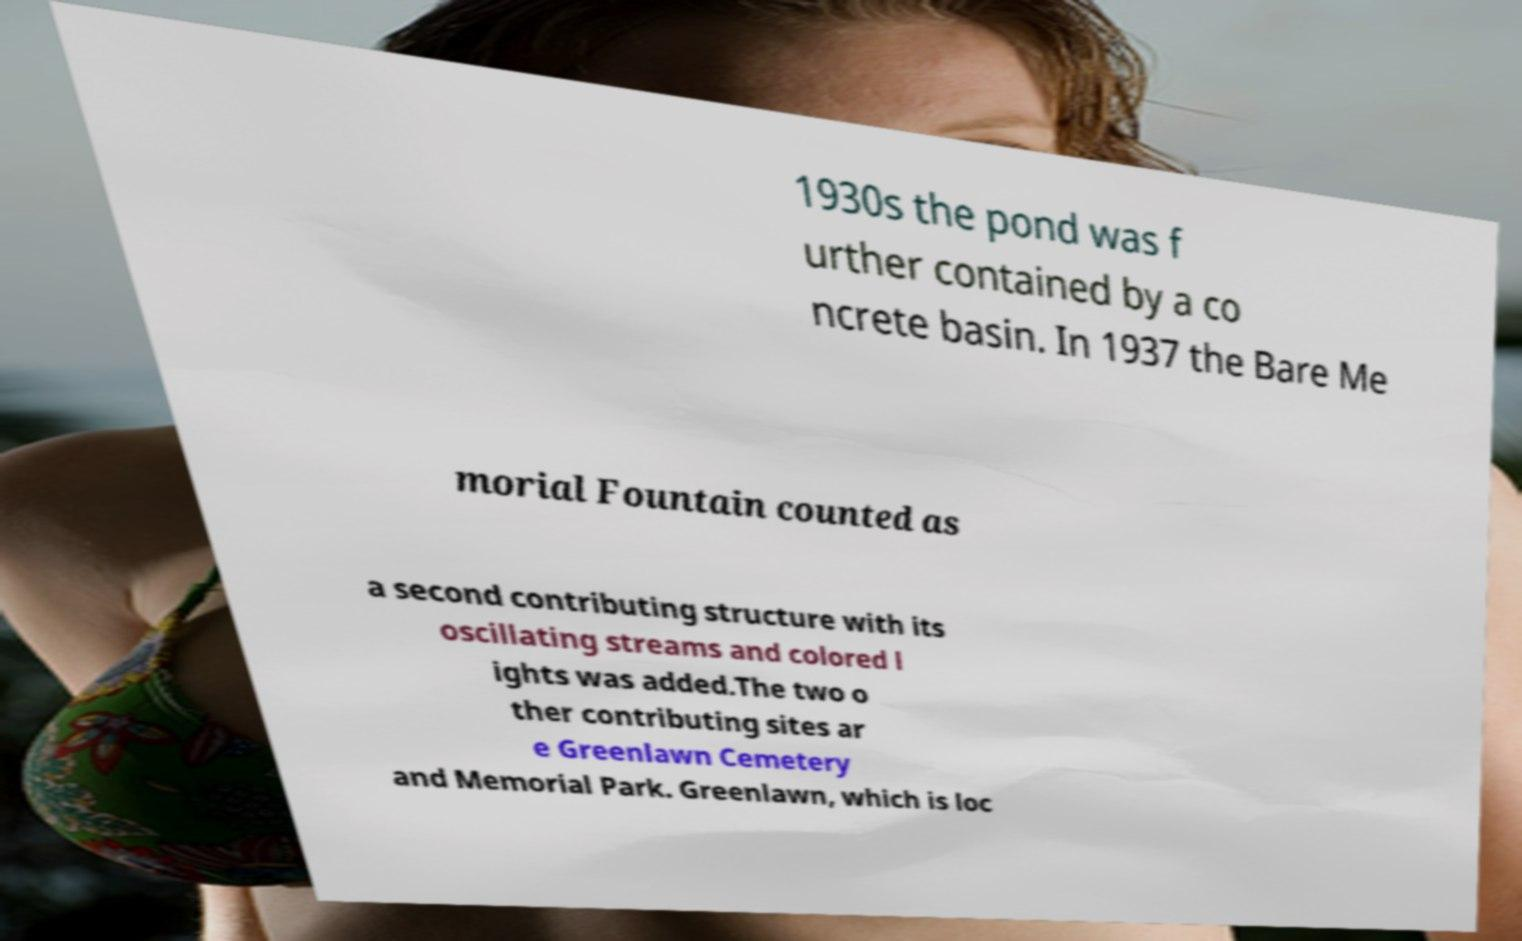For documentation purposes, I need the text within this image transcribed. Could you provide that? 1930s the pond was f urther contained by a co ncrete basin. In 1937 the Bare Me morial Fountain counted as a second contributing structure with its oscillating streams and colored l ights was added.The two o ther contributing sites ar e Greenlawn Cemetery and Memorial Park. Greenlawn, which is loc 